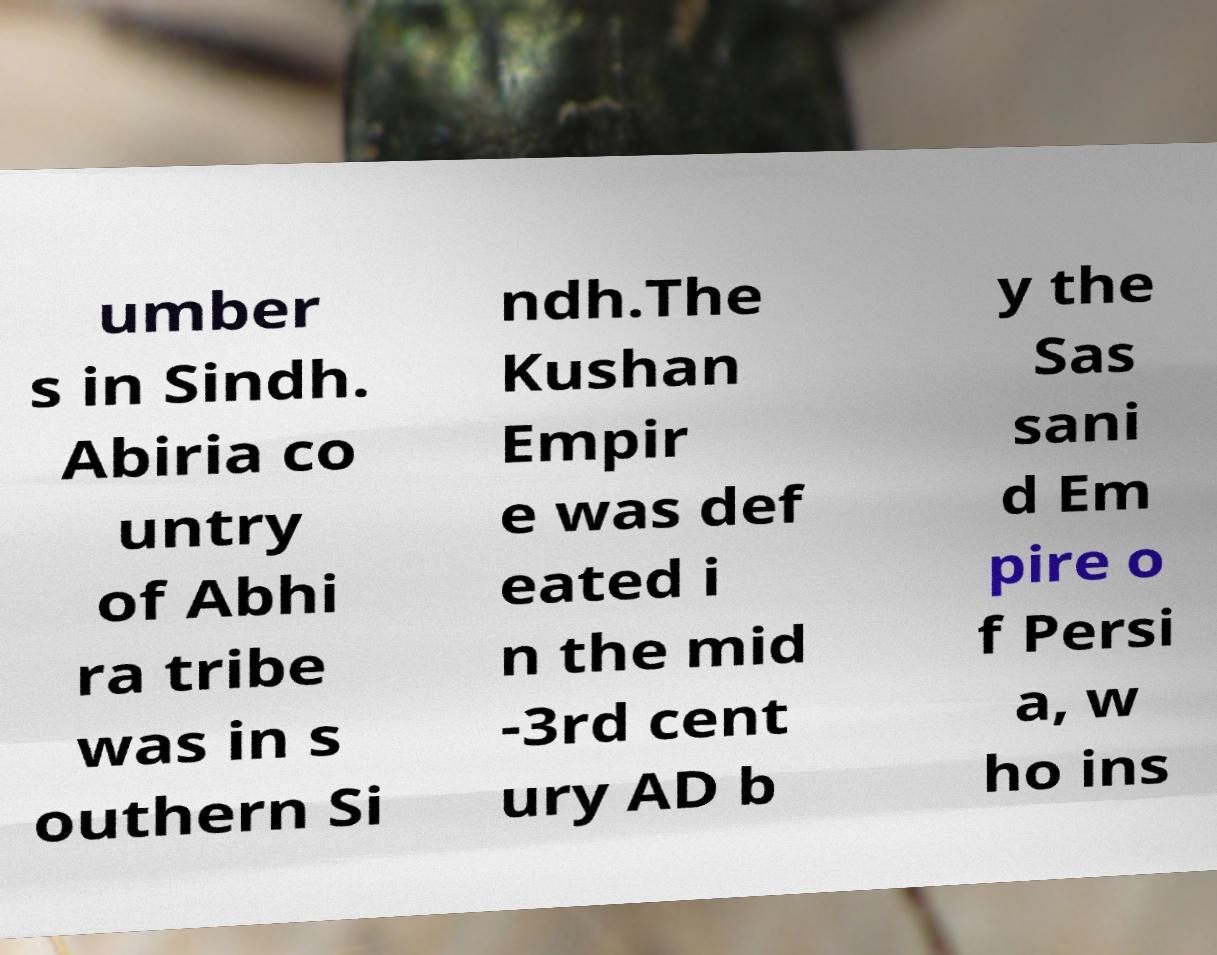I need the written content from this picture converted into text. Can you do that? umber s in Sindh. Abiria co untry of Abhi ra tribe was in s outhern Si ndh.The Kushan Empir e was def eated i n the mid -3rd cent ury AD b y the Sas sani d Em pire o f Persi a, w ho ins 